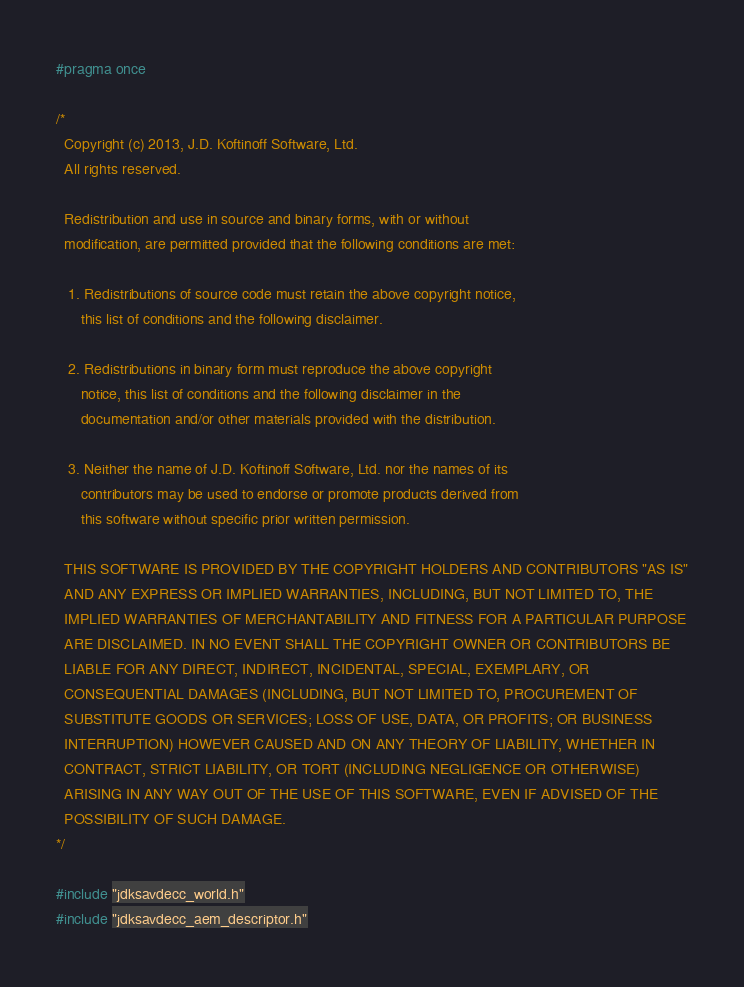<code> <loc_0><loc_0><loc_500><loc_500><_C_>#pragma once

/*
  Copyright (c) 2013, J.D. Koftinoff Software, Ltd.
  All rights reserved.

  Redistribution and use in source and binary forms, with or without
  modification, are permitted provided that the following conditions are met:

   1. Redistributions of source code must retain the above copyright notice,
      this list of conditions and the following disclaimer.

   2. Redistributions in binary form must reproduce the above copyright
      notice, this list of conditions and the following disclaimer in the
      documentation and/or other materials provided with the distribution.

   3. Neither the name of J.D. Koftinoff Software, Ltd. nor the names of its
      contributors may be used to endorse or promote products derived from
      this software without specific prior written permission.

  THIS SOFTWARE IS PROVIDED BY THE COPYRIGHT HOLDERS AND CONTRIBUTORS "AS IS"
  AND ANY EXPRESS OR IMPLIED WARRANTIES, INCLUDING, BUT NOT LIMITED TO, THE
  IMPLIED WARRANTIES OF MERCHANTABILITY AND FITNESS FOR A PARTICULAR PURPOSE
  ARE DISCLAIMED. IN NO EVENT SHALL THE COPYRIGHT OWNER OR CONTRIBUTORS BE
  LIABLE FOR ANY DIRECT, INDIRECT, INCIDENTAL, SPECIAL, EXEMPLARY, OR
  CONSEQUENTIAL DAMAGES (INCLUDING, BUT NOT LIMITED TO, PROCUREMENT OF
  SUBSTITUTE GOODS OR SERVICES; LOSS OF USE, DATA, OR PROFITS; OR BUSINESS
  INTERRUPTION) HOWEVER CAUSED AND ON ANY THEORY OF LIABILITY, WHETHER IN
  CONTRACT, STRICT LIABILITY, OR TORT (INCLUDING NEGLIGENCE OR OTHERWISE)
  ARISING IN ANY WAY OUT OF THE USE OF THIS SOFTWARE, EVEN IF ADVISED OF THE
  POSSIBILITY OF SUCH DAMAGE.
*/

#include "jdksavdecc_world.h"
#include "jdksavdecc_aem_descriptor.h"</code> 